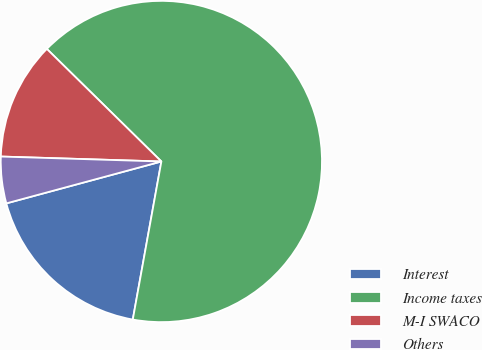Convert chart to OTSL. <chart><loc_0><loc_0><loc_500><loc_500><pie_chart><fcel>Interest<fcel>Income taxes<fcel>M-I SWACO<fcel>Others<nl><fcel>17.95%<fcel>65.48%<fcel>11.87%<fcel>4.69%<nl></chart> 